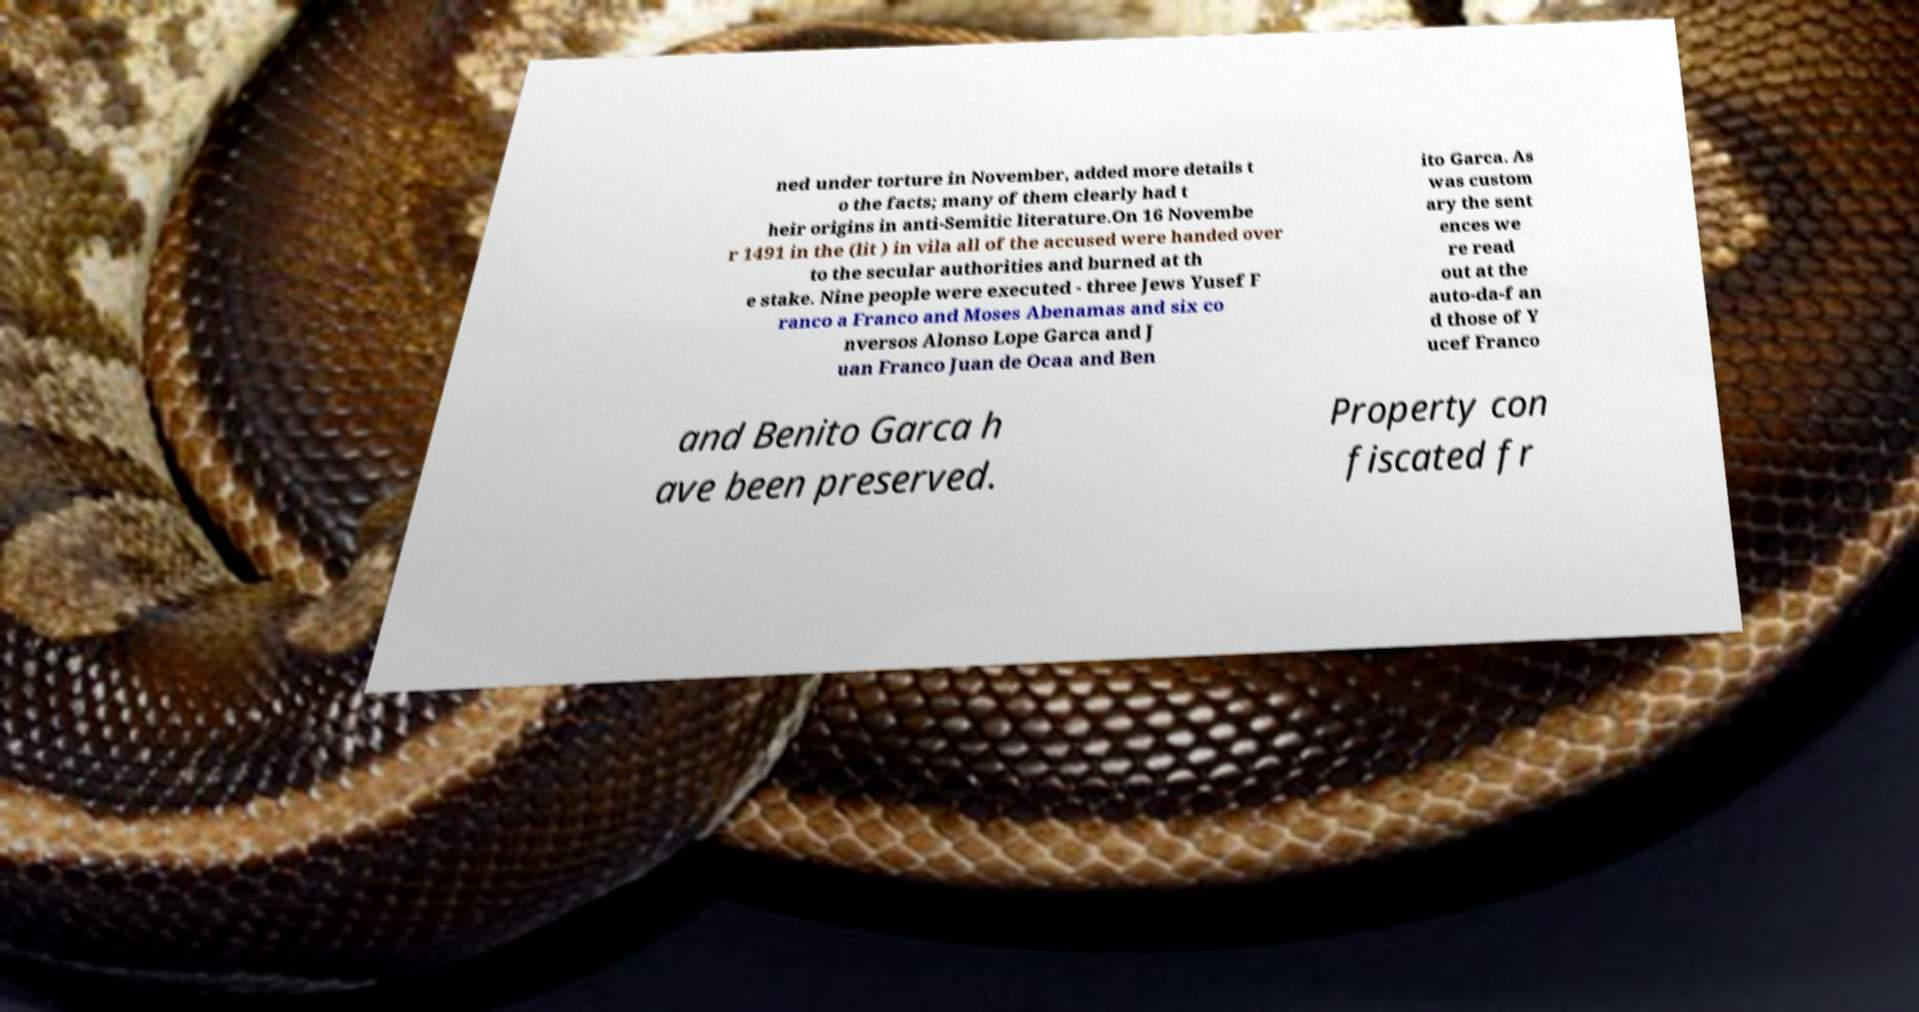Could you extract and type out the text from this image? ned under torture in November, added more details t o the facts; many of them clearly had t heir origins in anti-Semitic literature.On 16 Novembe r 1491 in the (lit ) in vila all of the accused were handed over to the secular authorities and burned at th e stake. Nine people were executed - three Jews Yusef F ranco a Franco and Moses Abenamas and six co nversos Alonso Lope Garca and J uan Franco Juan de Ocaa and Ben ito Garca. As was custom ary the sent ences we re read out at the auto-da-f an d those of Y ucef Franco and Benito Garca h ave been preserved. Property con fiscated fr 